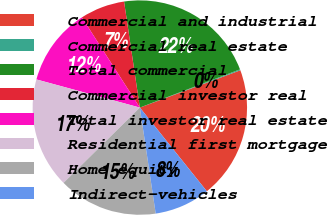Convert chart. <chart><loc_0><loc_0><loc_500><loc_500><pie_chart><fcel>Commercial and industrial<fcel>Commercial real estate<fcel>Total commercial<fcel>Commercial investor real<fcel>Total investor real estate<fcel>Residential first mortgage<fcel>Home equity<fcel>Indirect-vehicles<nl><fcel>19.91%<fcel>0.15%<fcel>21.55%<fcel>6.74%<fcel>11.68%<fcel>16.62%<fcel>14.97%<fcel>8.38%<nl></chart> 